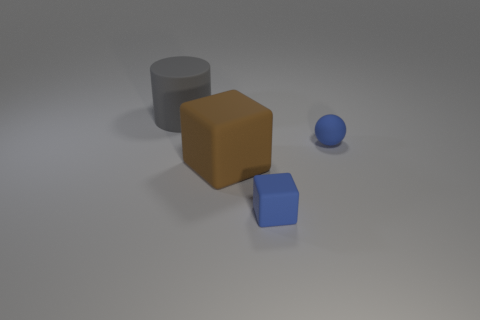Could you describe the lighting and shadows in the image? Certainly. There is a soft and diffused lighting coming from the upper left, creating gentle shadows to the right of the objects. The shadows are soft-edged, indicating that the light source isn't overly harsh or direct. 